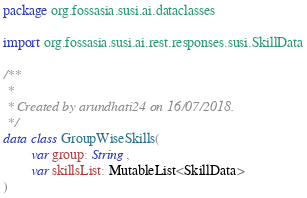Convert code to text. <code><loc_0><loc_0><loc_500><loc_500><_Kotlin_>package org.fossasia.susi.ai.dataclasses

import org.fossasia.susi.ai.rest.responses.susi.SkillData

/**
 *
 * Created by arundhati24 on 16/07/2018.
 */
data class GroupWiseSkills(
        var group: String,
        var skillsList: MutableList<SkillData>
)</code> 